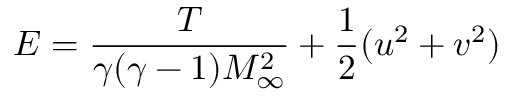<formula> <loc_0><loc_0><loc_500><loc_500>E = \frac { T } { \gamma ( \gamma - 1 ) M _ { \infty } ^ { 2 } } + \frac { 1 } { 2 } ( u ^ { 2 } + v ^ { 2 } )</formula> 